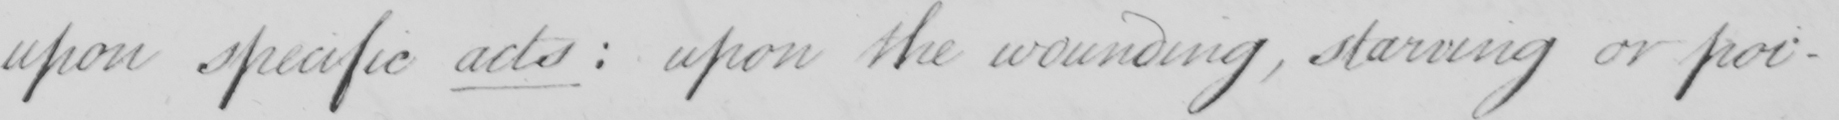Please provide the text content of this handwritten line. upon specific acts  :  upon the wounding  , starving or poi 